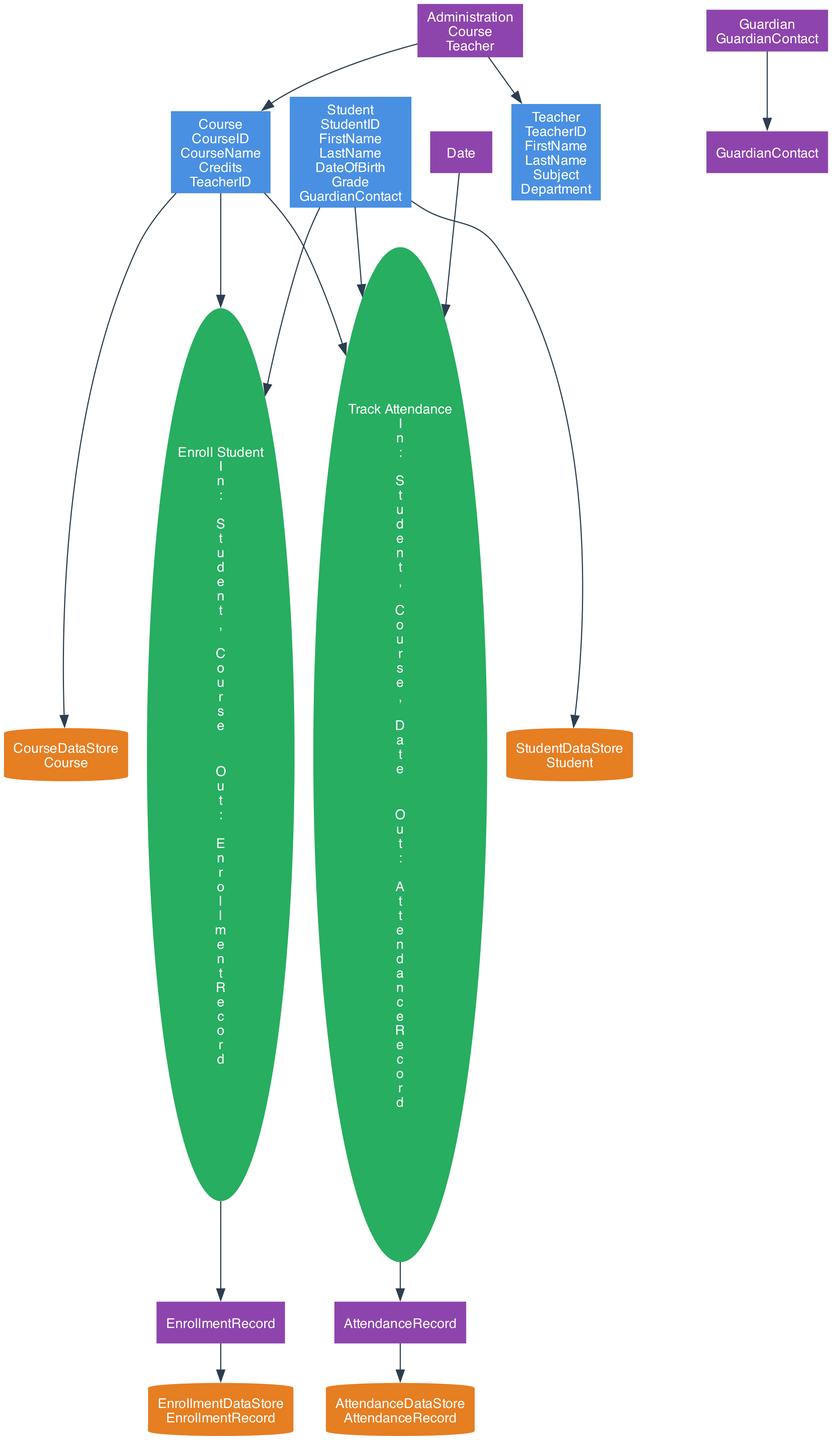What is the name of the first process in the diagram? The first process listed in the diagram is "Enroll Student." This can be identified by the order of the processes as shown in the description, where "Enroll Student" appears before "Track Attendance."
Answer: Enroll Student How many data stores are present in the diagram? The diagram includes four data stores: "StudentDataStore", "CourseDataStore", "EnrollmentDataStore", and "AttendanceDataStore." By counting these stores in the description, we see there are four distinct entities.
Answer: 4 Which external entity communicates with the "Student"? The "Guardian" is the external entity that communicates with the "Student," as indicated in the diagram where the "Guardian" is linked to the "Student" through the "GuardianContact" data.
Answer: Guardian What outputs are produced by the "Enroll Student" process? The output of the "Enroll Student" process is the "EnrollmentRecord." This is shown in the process section, where the output of the "Enroll Student" process is distinctly labeled as "EnrollmentRecord."
Answer: EnrollmentRecord What is the relationship between "Track Attendance" and "AttendanceRecord"? The "Track Attendance" process produces the "AttendanceRecord" as its output. This means that once the process is executed, the end result is the creation of an attendance record, establishing a direct output-output relationship.
Answer: AttendanceRecord How many inputs does the "Track Attendance" process have? The "Track Attendance" process has three inputs: "Student," "Course," and "Date," which can be directly observed in the input section of the process description. By enumerating these inputs, we come up with a total of three.
Answer: 3 What type of diagram is this? This is a Data Flow Diagram, as indicated by the structure and the elements represented within the diagram — specifically showing processes, data stores, external entities, and their interactions.
Answer: Data Flow Diagram What data is stored in "StudentDataStore"? The "StudentDataStore" contains "Student" data. This information is provided under the "data" section of the data store description, specifically indicating which types of data each store holds.
Answer: Student Which process takes "Course" as input? The "Enroll Student" and "Track Attendance" processes both take "Course" as an input. By reviewing the input sections for both processes, we can confirm this input is part of the requirement for both processes.
Answer: Enroll Student, Track Attendance 